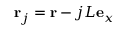<formula> <loc_0><loc_0><loc_500><loc_500>{ r } _ { j } = { r } - j L { e } _ { x }</formula> 